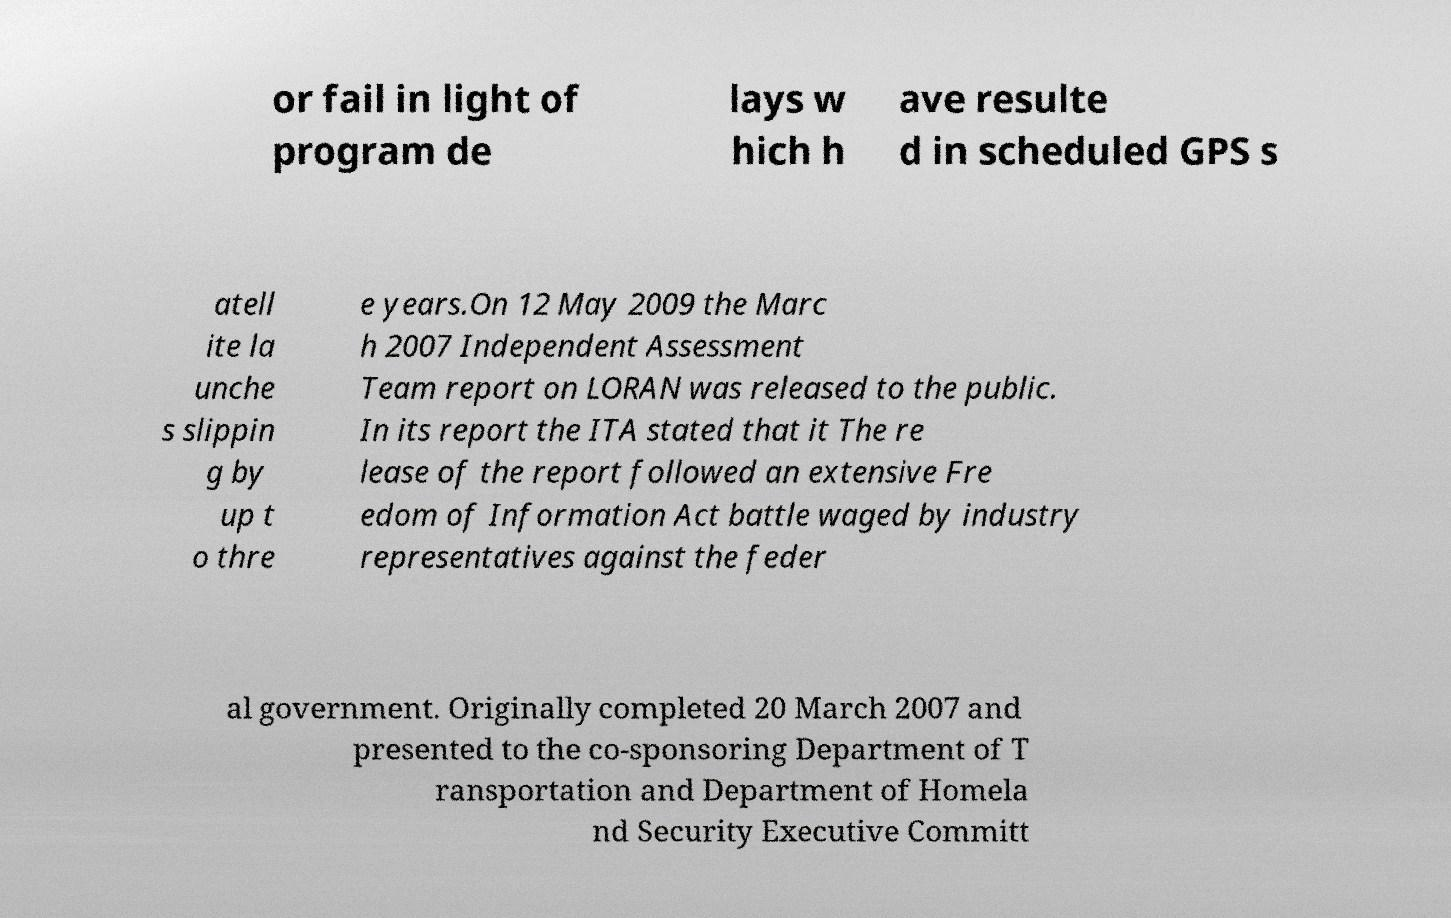I need the written content from this picture converted into text. Can you do that? or fail in light of program de lays w hich h ave resulte d in scheduled GPS s atell ite la unche s slippin g by up t o thre e years.On 12 May 2009 the Marc h 2007 Independent Assessment Team report on LORAN was released to the public. In its report the ITA stated that it The re lease of the report followed an extensive Fre edom of Information Act battle waged by industry representatives against the feder al government. Originally completed 20 March 2007 and presented to the co-sponsoring Department of T ransportation and Department of Homela nd Security Executive Committ 